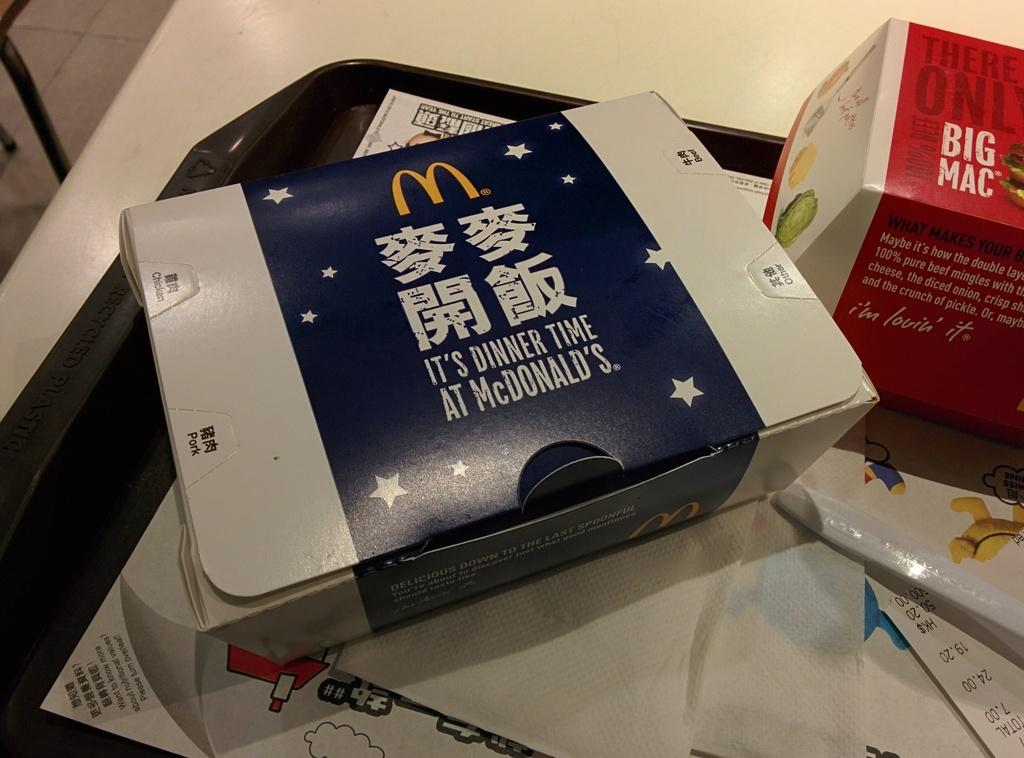<image>
Provide a brief description of the given image. A box saying It's Dinner Time At McDonald's. 